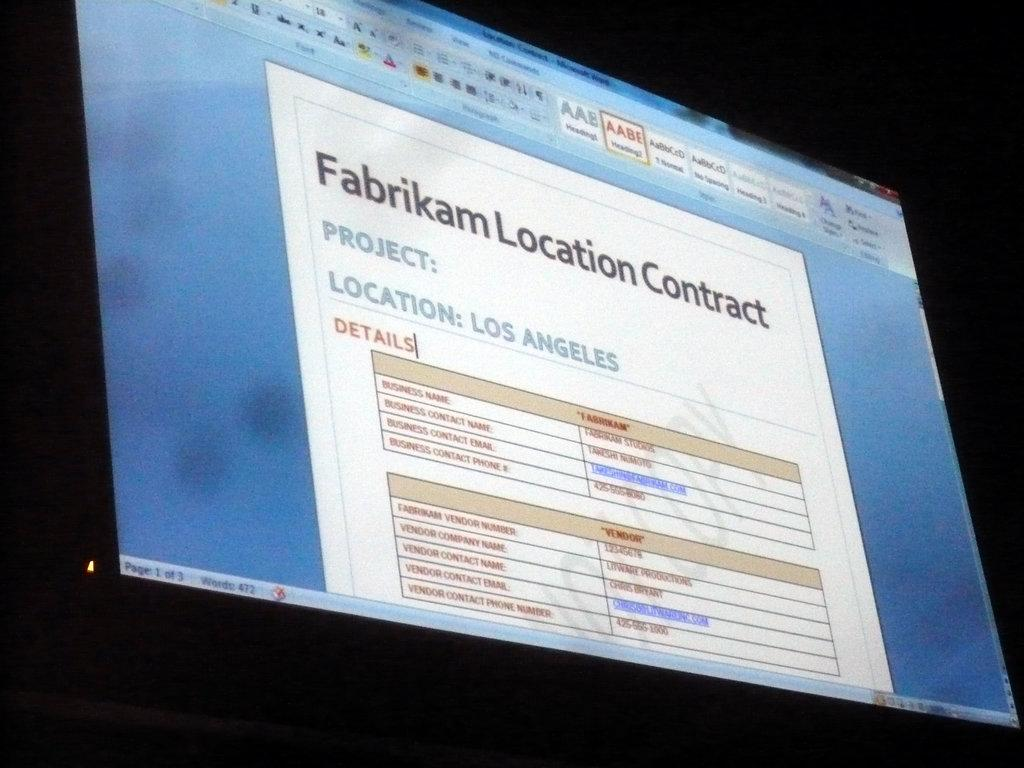<image>
Create a compact narrative representing the image presented. A computer monitor shows the Fabrikam Location Contract. 